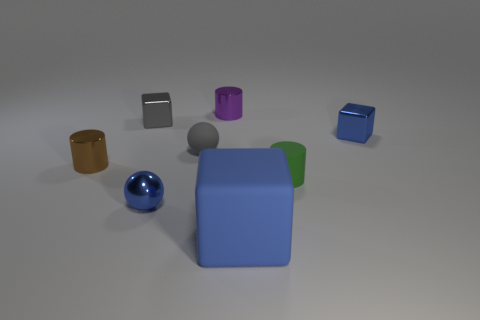How many cylinders are large red rubber objects or small blue metallic objects?
Ensure brevity in your answer.  0. What is the color of the metal block that is on the left side of the blue shiny object on the left side of the matte cylinder?
Your response must be concise. Gray. Are there fewer small green matte objects left of the small gray cube than tiny shiny cubes left of the green rubber cylinder?
Provide a succinct answer. Yes. Is the size of the blue metallic sphere the same as the blue matte thing that is left of the tiny green thing?
Your answer should be compact. No. The thing that is right of the big blue block and behind the green matte object has what shape?
Keep it short and to the point. Cube. What is the size of the block that is the same material as the green cylinder?
Provide a succinct answer. Large. There is a block in front of the rubber cylinder; how many tiny blue metallic things are behind it?
Provide a short and direct response. 2. Is the material of the blue cube that is in front of the small brown metallic object the same as the gray sphere?
Your answer should be very brief. Yes. What size is the blue cube in front of the small blue metal object that is in front of the brown object?
Keep it short and to the point. Large. How big is the rubber block on the right side of the tiny cylinder that is left of the tiny metallic cylinder to the right of the gray matte sphere?
Ensure brevity in your answer.  Large. 